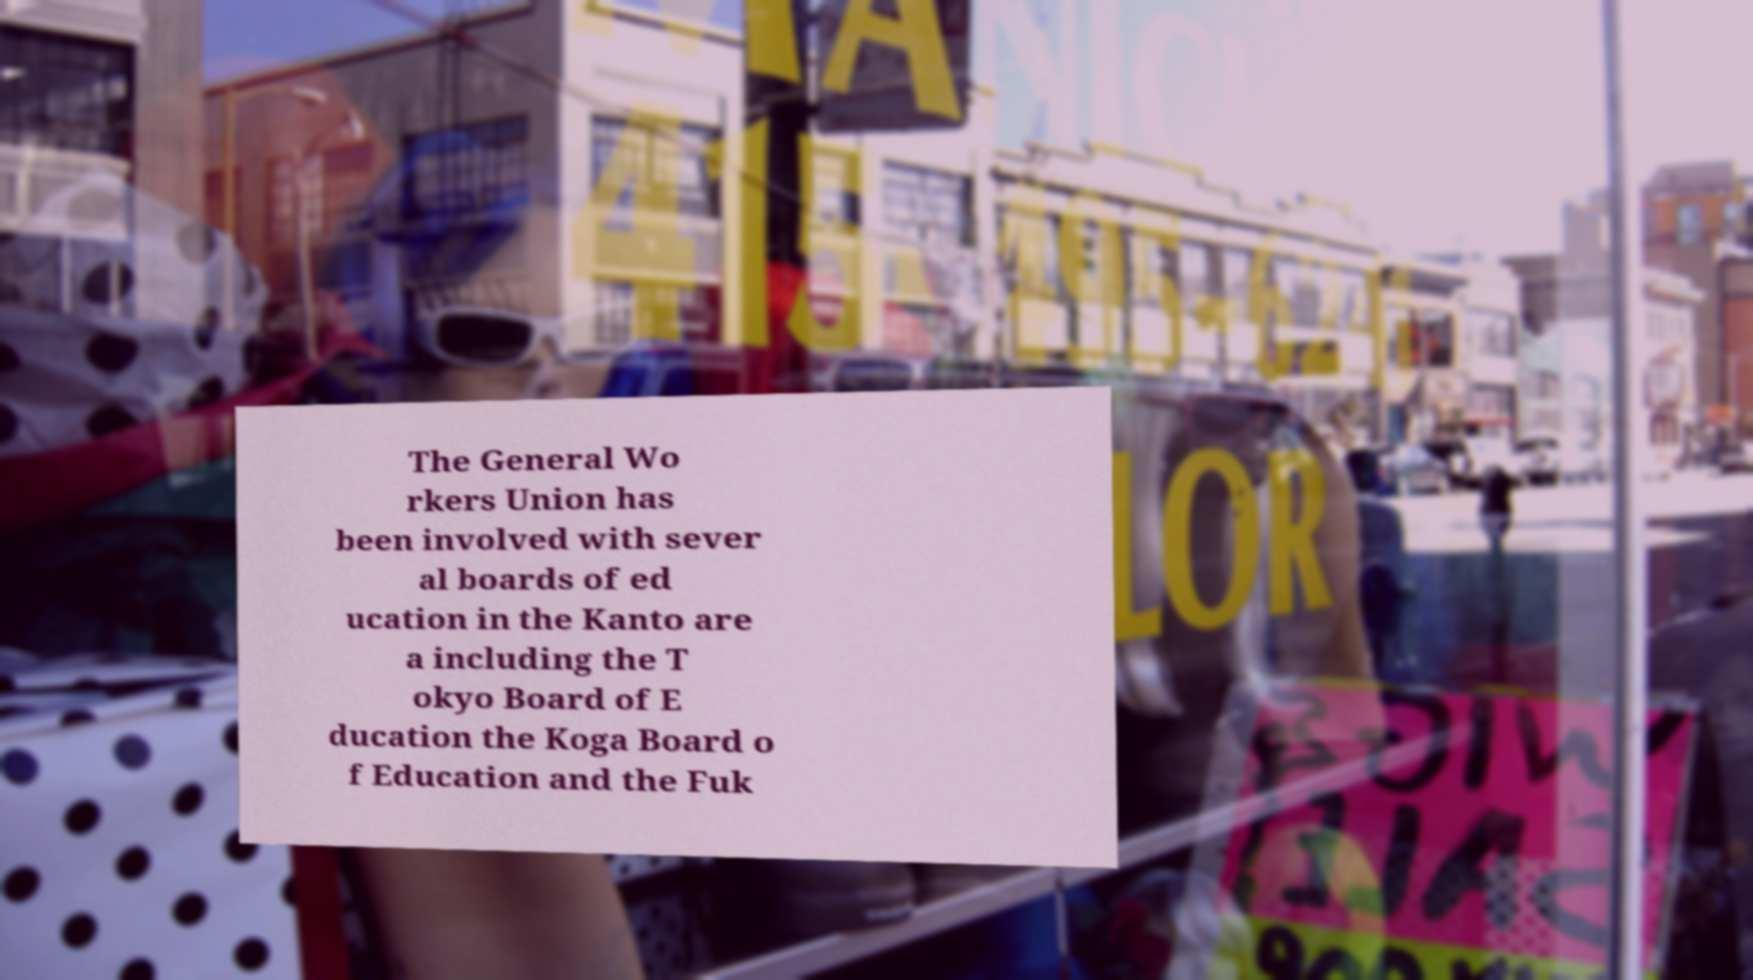What messages or text are displayed in this image? I need them in a readable, typed format. The General Wo rkers Union has been involved with sever al boards of ed ucation in the Kanto are a including the T okyo Board of E ducation the Koga Board o f Education and the Fuk 